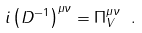<formula> <loc_0><loc_0><loc_500><loc_500>i \left ( D ^ { - 1 } \right ) ^ { \mu \nu } = \Pi _ { V } ^ { \mu \nu } \ .</formula> 